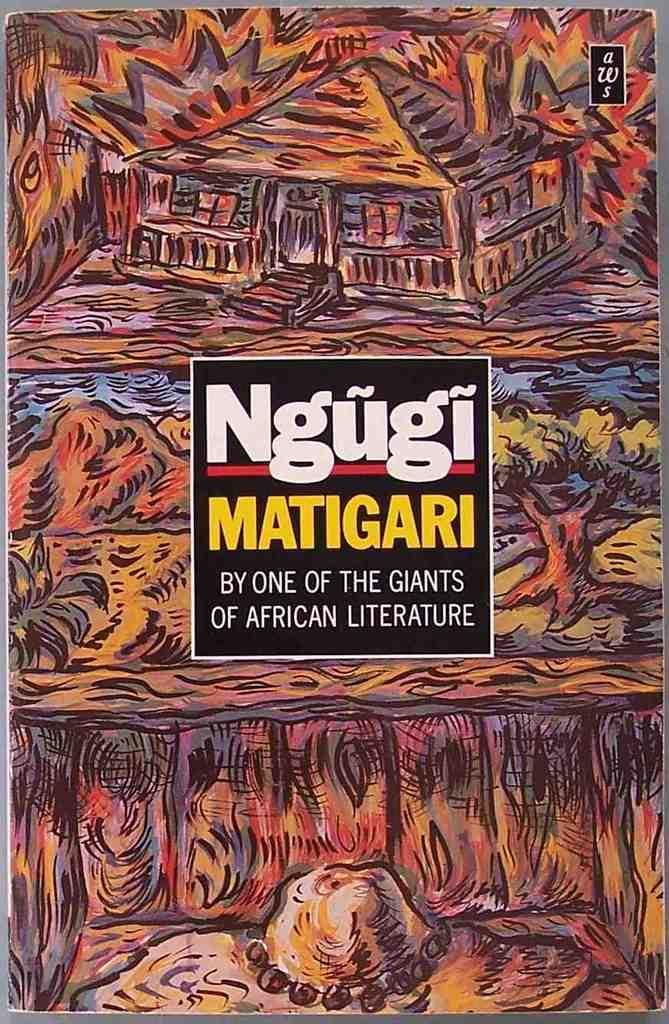Provide a one-sentence caption for the provided image. The colorful cover of Ngugi Matigari book displays African culture. 